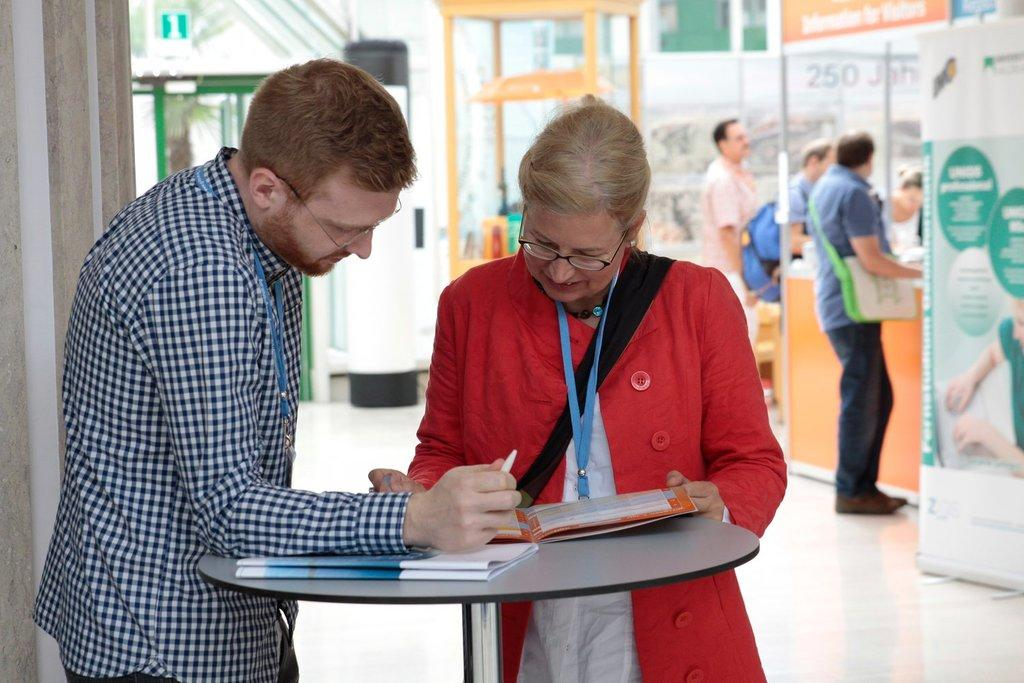How many people are present in the image? There are 2 people in the image. What are the people doing near the round table? The people are going through a file. Can you describe the setting where the people are located? The people are standing near a round table. Are there any other people visible in the image? Yes, there are other people visible in the background of the image. What language are the people using to communicate in the image? The provided facts do not mention the language being used by the people in the image. --- Facts: 1. There is a car in the image. 2. The car is parked on the street. 3. The car has a flat tire. 4. There are people walking on the sidewalk. 5. The weather appears to be sunny. Absurd Topics: dance, swim, paint Conversation: What is the main subject of the image? The main subject of the image is a car. Where is the car located in the image? The car is parked on the street. What is the condition of the car's tires? The car has a flat tire. Can you describe the surroundings of the car? There are people walking on the sidewalk. How would you describe the weather in the image? The weather appears to be sunny. Reasoning: Let's think step by step in order to produce the conversation. We start by identifying the main subject of the image, which is the car. Then, we describe the car's location, mentioning that it is parked on the street. Next, we provide information about the car's condition, noting that it has a flat tire. We then expand the conversation to include the surroundings, mentioning the people walking on the sidewalk. Finally, we describe the weather, noting that it appears to be sunny. Absurd Question/Answer: Are the people in the image dancing in the street? There is no indication in the image that the people are dancing; they are walking on the sidewalk. 